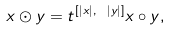Convert formula to latex. <formula><loc_0><loc_0><loc_500><loc_500>x \odot y = t ^ { [ | x | , \ | y | ] } x \circ y ,</formula> 